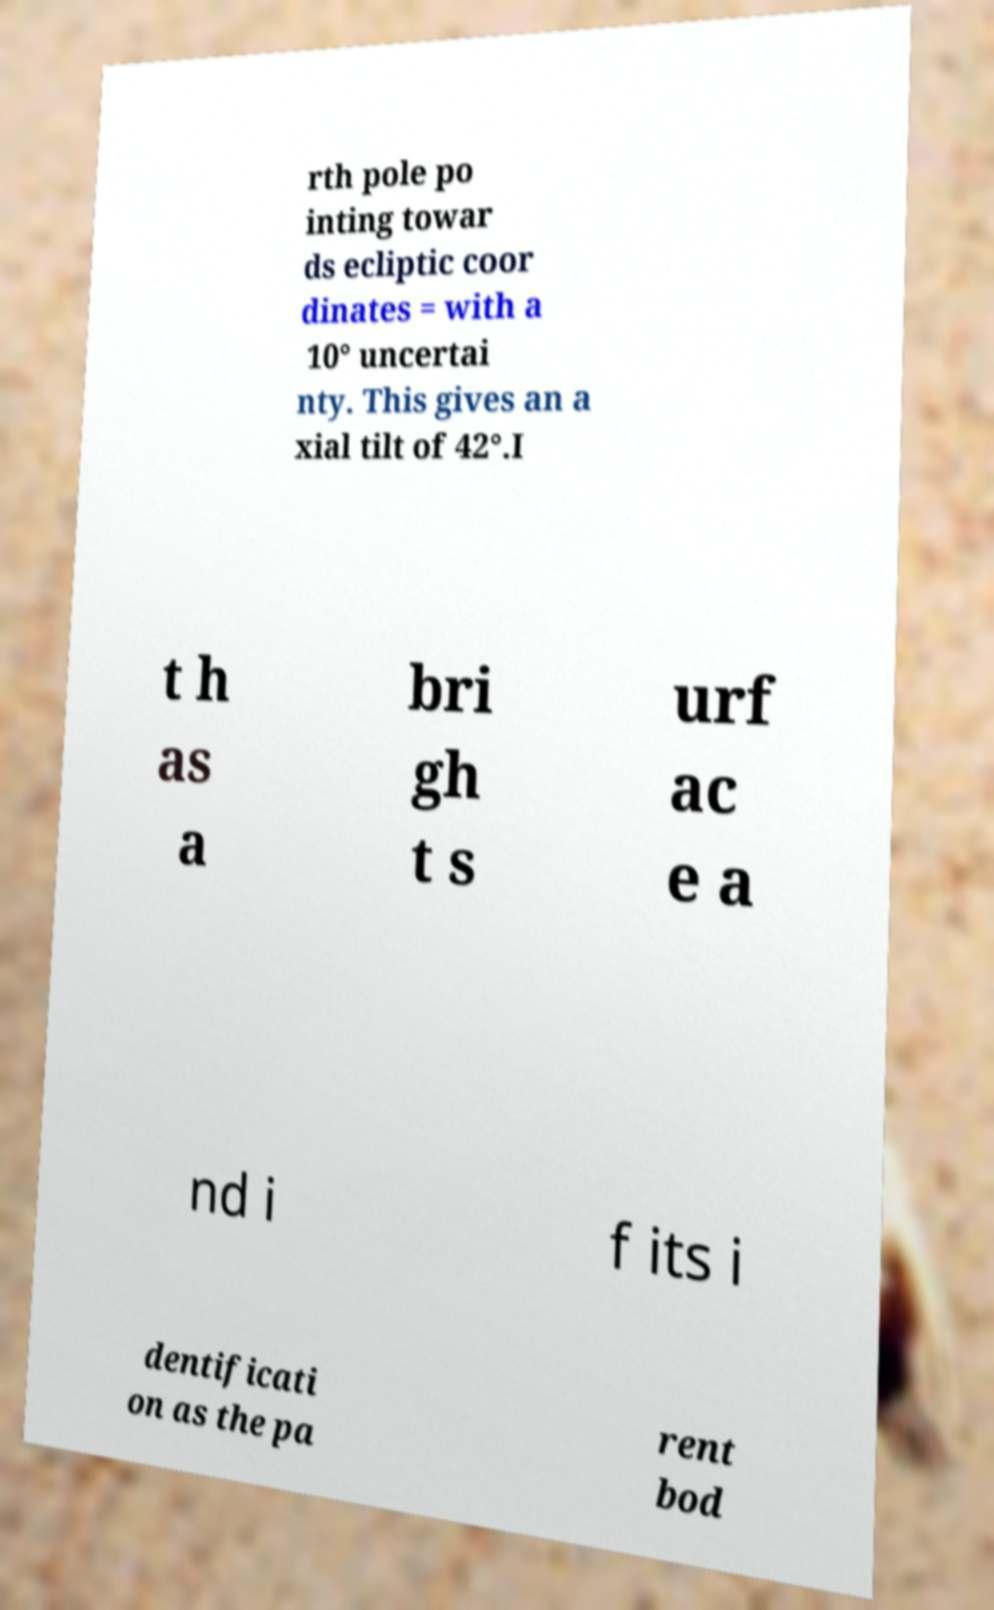There's text embedded in this image that I need extracted. Can you transcribe it verbatim? rth pole po inting towar ds ecliptic coor dinates = with a 10° uncertai nty. This gives an a xial tilt of 42°.I t h as a bri gh t s urf ac e a nd i f its i dentificati on as the pa rent bod 